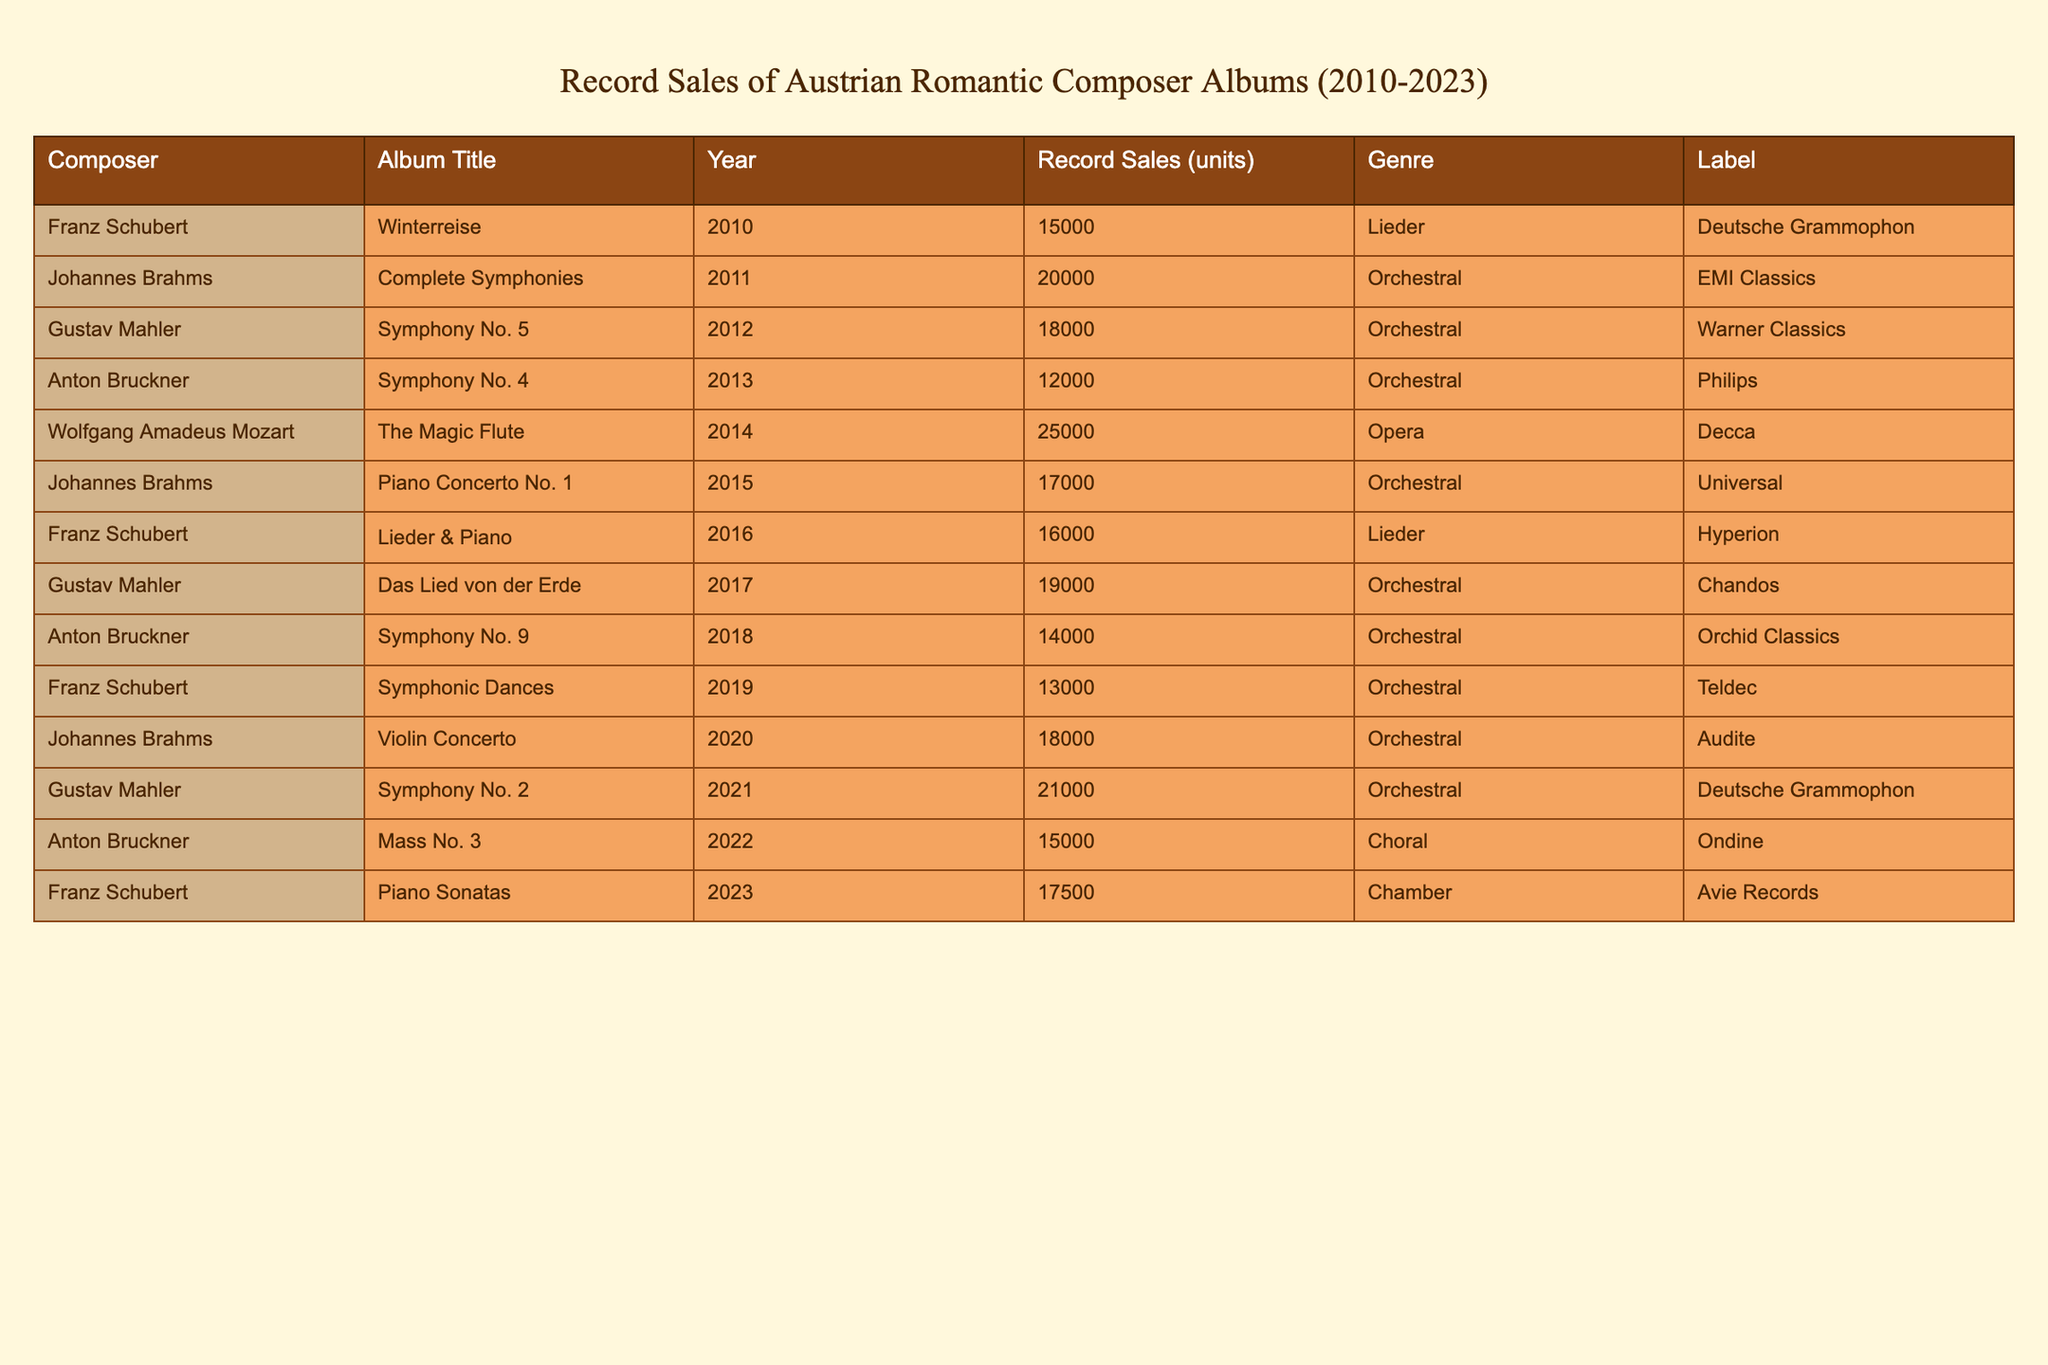What is the total record sales of all albums by Johannes Brahms from 2010 to 2023? First, look at the table for Johannes Brahms' albums: "Complete Symphonies" (2011) with 20000 units, "Piano Concerto No. 1" (2015) with 17000 units, and "Violin Concerto" (2020) with 18000 units. Now, add these sales: 20000 + 17000 + 18000 = 55000 units.
Answer: 55000 Which album from Gustav Mahler had the highest record sales? The table shows the albums by Gustav Mahler: "Symphony No. 5" (2012) with 18000 units, "Das Lied von der Erde" (2017) with 19000 units, and "Symphony No. 2" (2021) with 21000 units. The highest sales are from "Symphony No. 2" with 21000 units.
Answer: Symphony No. 2 Did any albums released in 2014 have higher sales than 20000 units? In the table, the only album released in 2014 is "The Magic Flute" by Wolfgang Amadeus Mozart with 25000 units. Since this is greater than 20000, the answer is yes.
Answer: Yes What is the average record sales of all albums released in 2019 and earlier? First, list the number of albums and their sales: "Winterreise" (15000), "Complete Symphonies" (20000), "Symphony No. 5" (18000), "Symphony No. 4" (12000), "The Magic Flute" (25000), "Piano Concerto No. 1" (17000), "Lieder & Piano" (16000), "Das Lied von der Erde" (19000), "Symphony No. 9" (14000), and "Symphonic Dances" (13000). The total sales sum is 15000 + 20000 + 18000 + 12000 + 25000 + 17000 + 16000 + 19000 + 14000 + 13000 = 180000 units. There are 10 albums, so the average is 180000/10 = 18000.
Answer: 18000 How many albums were released by Franz Schubert during the period? Looking through the table, Franz Schubert has three albums: "Winterreise" (2010), "Lieder & Piano" (2016), and "Symphonic Dances" (2019). Therefore, the total count is 3 albums.
Answer: 3 